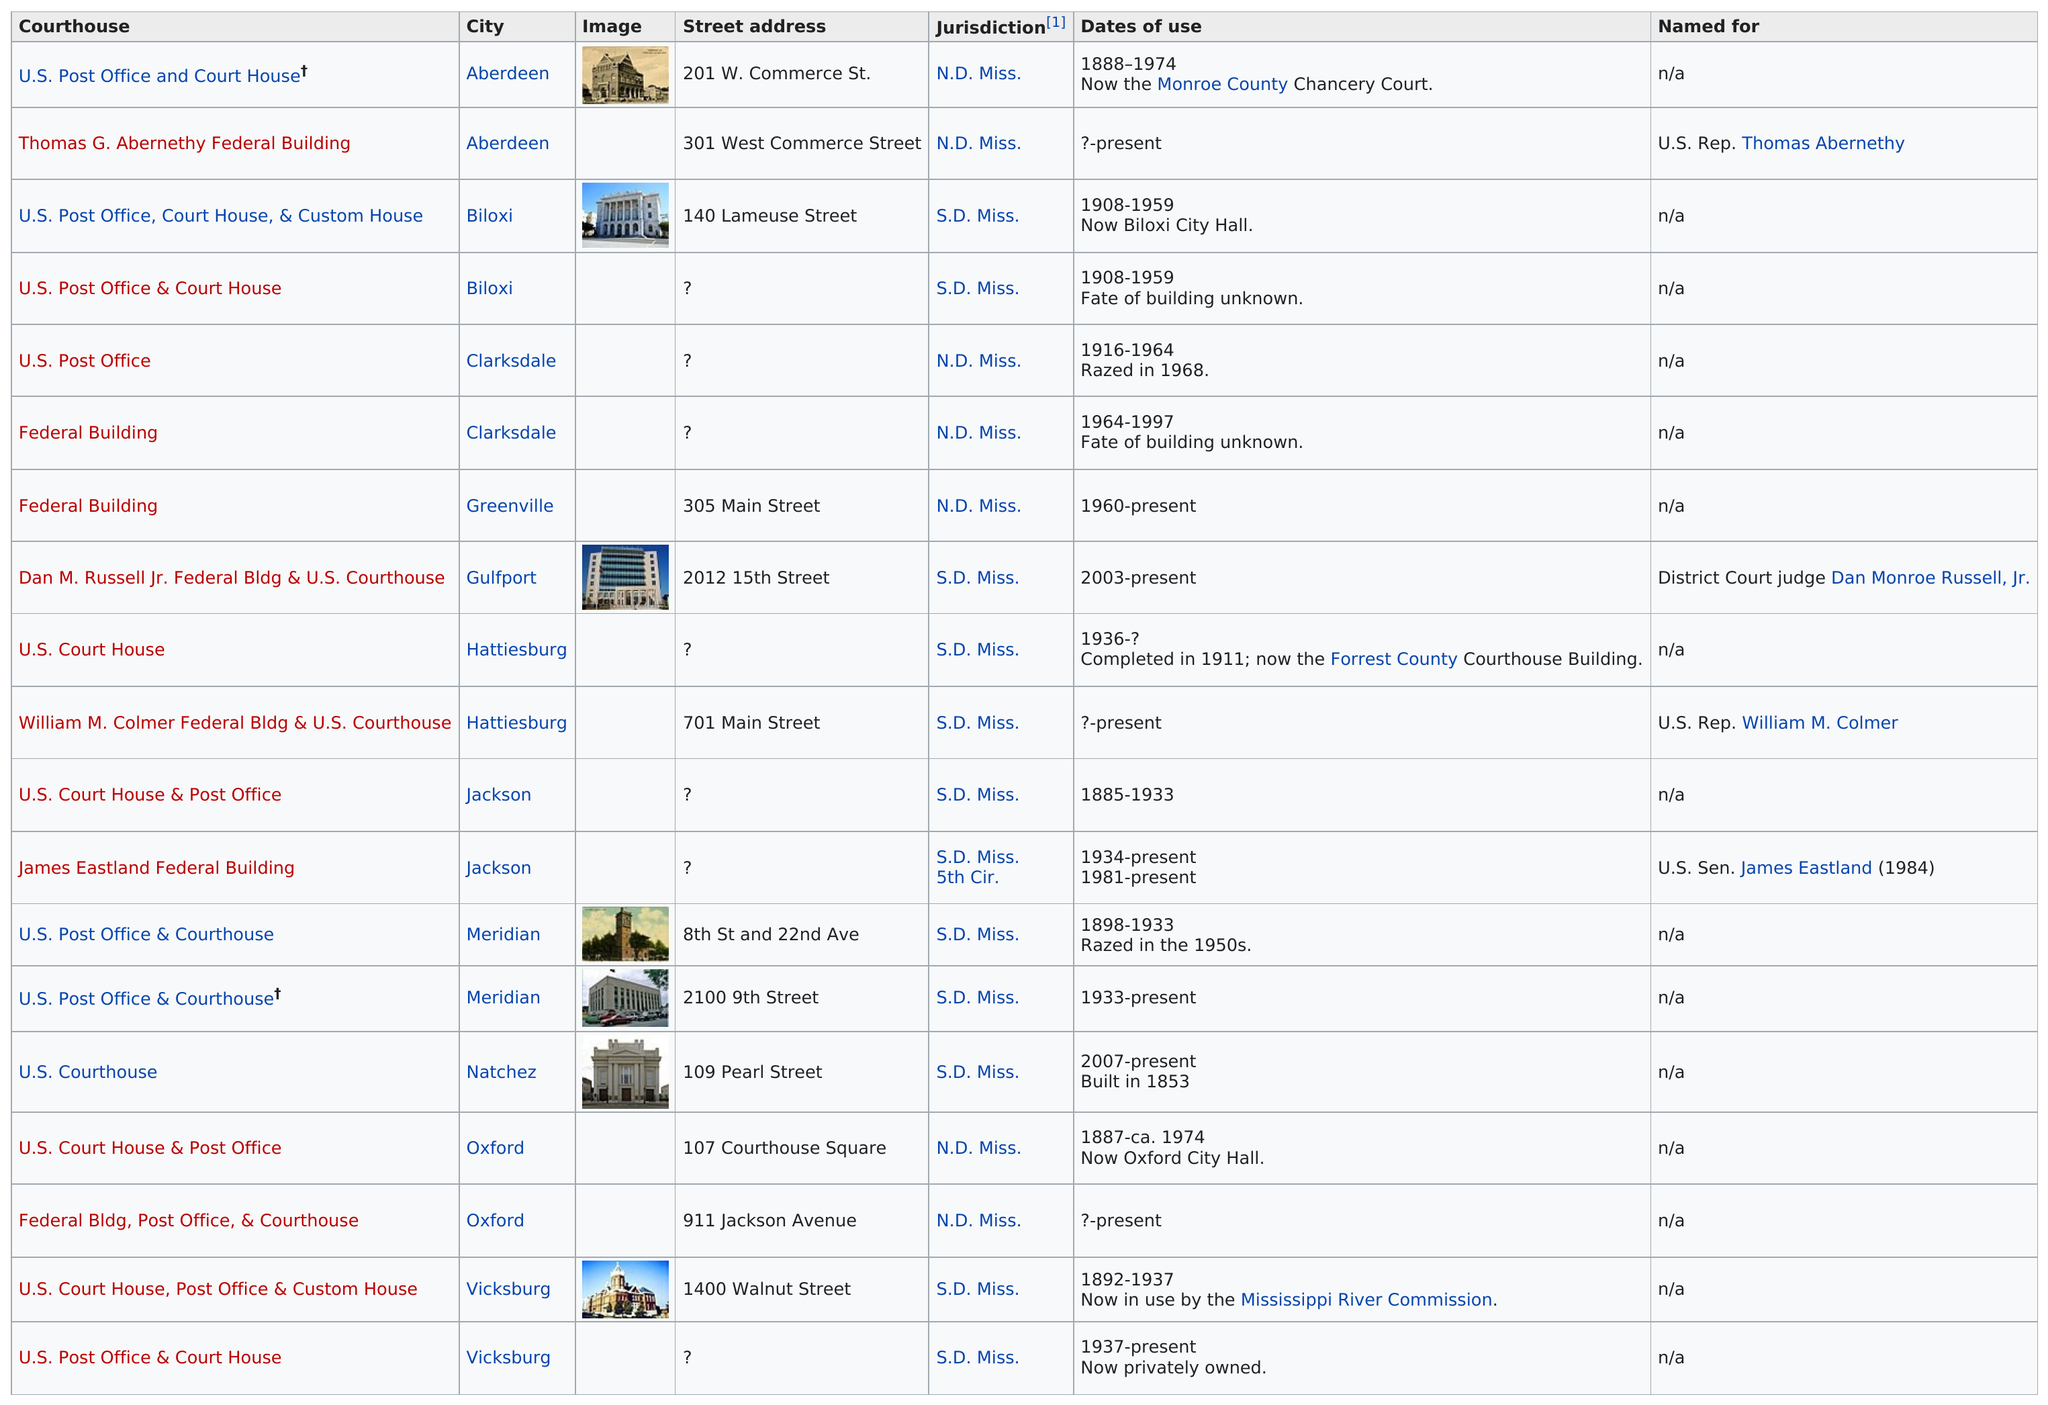Indicate a few pertinent items in this graphic. There are two courthouses located in Biloxi. The Dan M. Russell Jr. Federal Bldg & U.S. Courthouse in Gulfport is the only courthouse listed. The Dan M. Russell Jr. Federal Building and U.S. Courthouse is the name of a courthouse that is listed after the Federal Building. There were 7 courthouses in the jurisdiction of N.D. in the year 2022. The Thomas G. Abernethy Federal Building is located in the same city as the U.S. Post Office and Court House. 